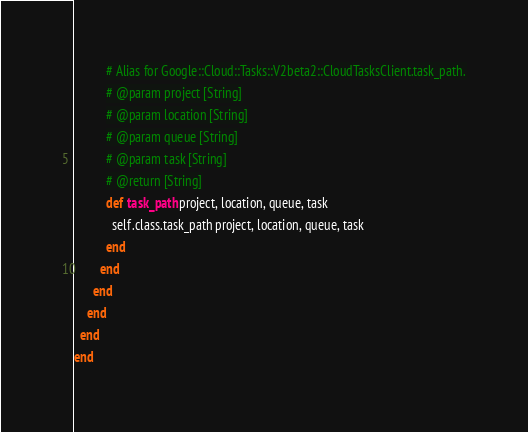<code> <loc_0><loc_0><loc_500><loc_500><_Ruby_>          # Alias for Google::Cloud::Tasks::V2beta2::CloudTasksClient.task_path.
          # @param project [String]
          # @param location [String]
          # @param queue [String]
          # @param task [String]
          # @return [String]
          def task_path project, location, queue, task
            self.class.task_path project, location, queue, task
          end
        end
      end
    end
  end
end</code> 